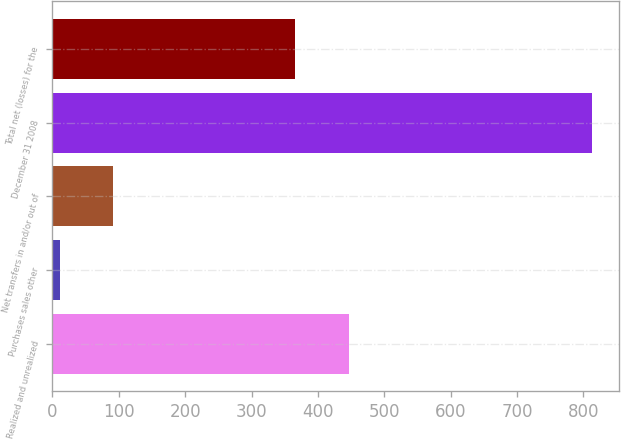Convert chart to OTSL. <chart><loc_0><loc_0><loc_500><loc_500><bar_chart><fcel>Realized and unrealized<fcel>Purchases sales other<fcel>Net transfers in and/or out of<fcel>December 31 2008<fcel>Total net (losses) for the<nl><fcel>446.2<fcel>11<fcel>91.2<fcel>813<fcel>366<nl></chart> 